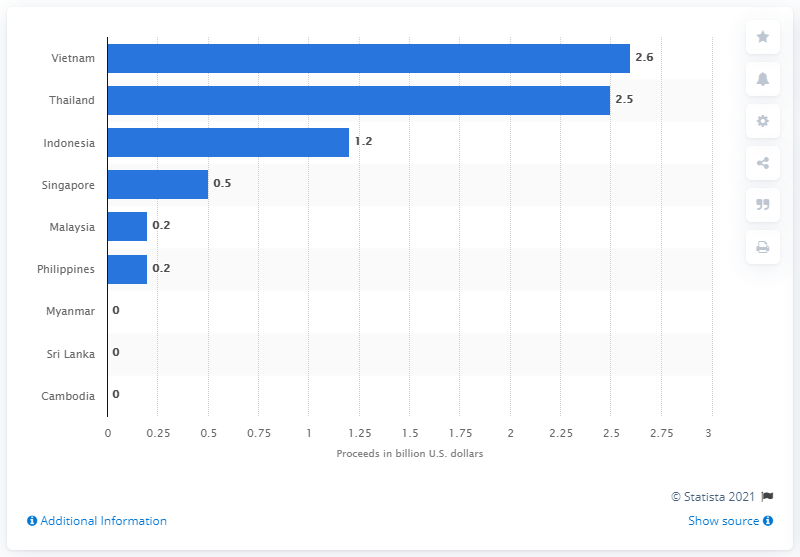Outline some significant characteristics in this image. Vietnam's initial public offerings (IPOs) raised a total of 2.6 billion US dollars. In 2018, the Thai stock exchange raised 2.5 billion U.S. dollars through initial public offerings (IPOs). 